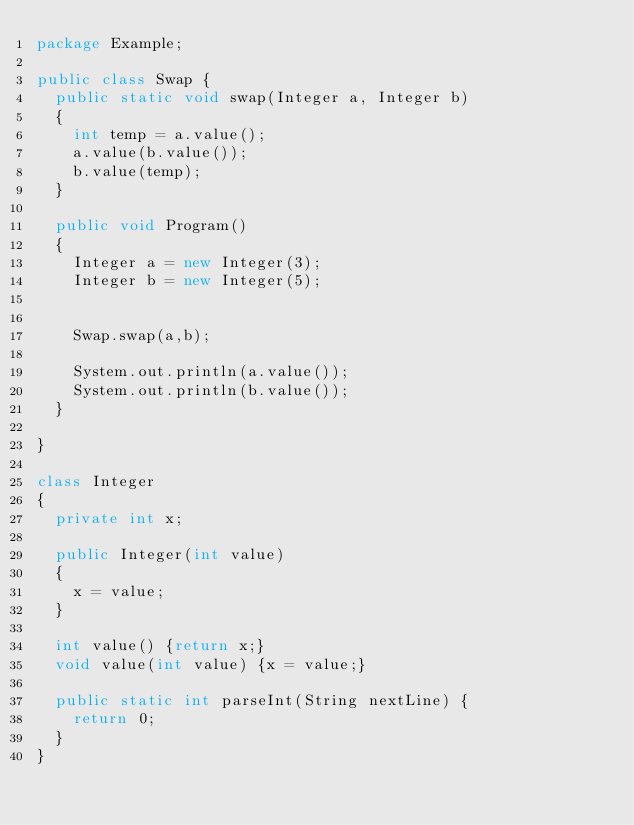<code> <loc_0><loc_0><loc_500><loc_500><_Java_>package Example;

public class Swap {
	public static void swap(Integer a, Integer b)
	{
		int temp = a.value();
		a.value(b.value());
		b.value(temp);
	}
	
	public void Program()
	{
		Integer a = new Integer(3);
		Integer b = new Integer(5);
		
		
		Swap.swap(a,b);
		
		System.out.println(a.value());
		System.out.println(b.value());
	}

}

class Integer
{
	private int x;
	
	public Integer(int value)
	{
		x = value;
	}
	
	int value() {return x;}
	void value(int value) {x = value;}

	public static int parseInt(String nextLine) {
		return 0;
	}
}</code> 